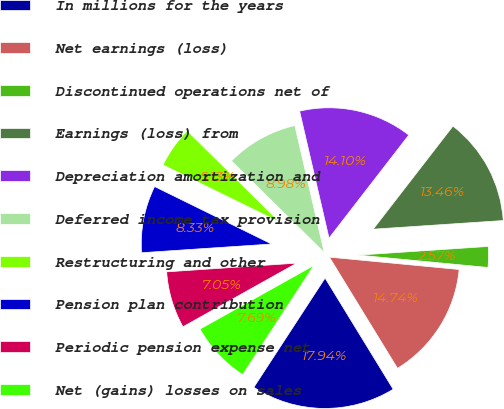Convert chart. <chart><loc_0><loc_0><loc_500><loc_500><pie_chart><fcel>In millions for the years<fcel>Net earnings (loss)<fcel>Discontinued operations net of<fcel>Earnings (loss) from<fcel>Depreciation amortization and<fcel>Deferred income tax provision<fcel>Restructuring and other<fcel>Pension plan contribution<fcel>Periodic pension expense net<fcel>Net (gains) losses on sales<nl><fcel>17.94%<fcel>14.74%<fcel>2.57%<fcel>13.46%<fcel>14.1%<fcel>8.98%<fcel>5.13%<fcel>8.33%<fcel>7.05%<fcel>7.69%<nl></chart> 